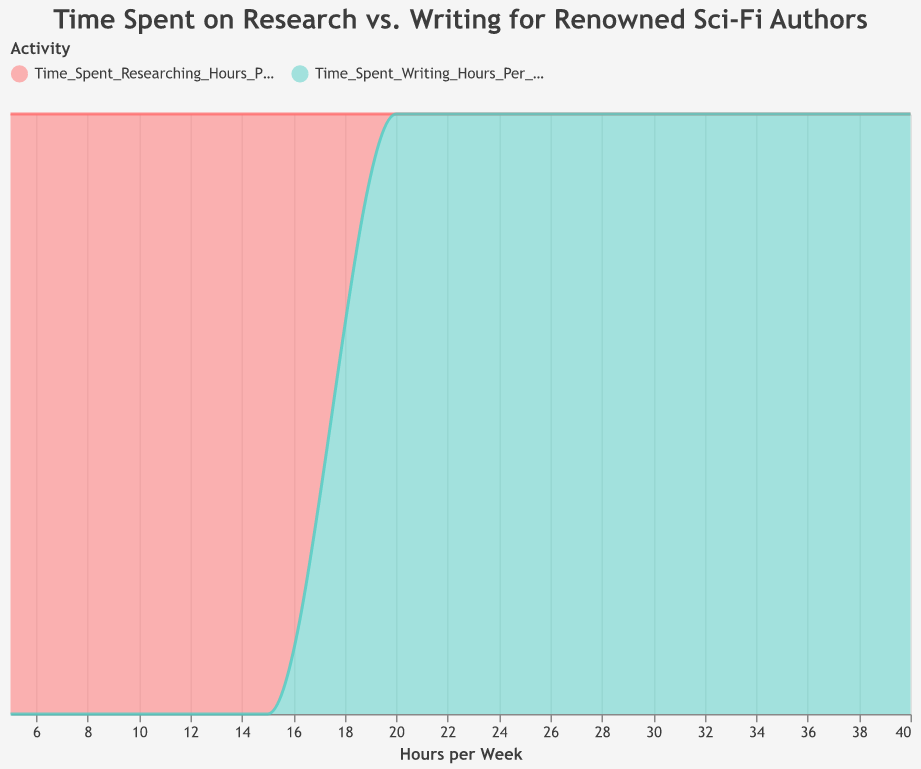How many different activities are plotted in the density plot? Look at the legend in the figure, which specifies the different activities plotted. In this case, the legend mentions "Researching" and "Writing".
Answer: 2 What is the activity associated with a given red color? Check the colors in the legend. The red color corresponds to one of the plotted activities. Based on the information, red is for "Researching".
Answer: Researching Which activity has a higher peak density, researching or writing? Observe the density curves for both activities. The peak of the green curve representing "Writing" is higher than the red curve representing "Researching".
Answer: Writing At what hour value do both activities intersect in their density plots? Look at the point where the red (Researching) and green (Writing) curves intersect on the x-axis. This occurs around 10 hours per week.
Answer: 10 hours Who spends the least amount of time researching per week? Identify the author with the minimum value on the research axis. Ray Bradbury spends the least time researching at 5 hours per week.
Answer: Ray Bradbury Which authors spend between 10 and 15 hours researching and 30 to 35 hours writing per week? From the table given, filter out authors who meet this criterion. Isaac Asimov and H.G. Wells fit these criteria.
Answer: Isaac Asimov and H.G. Wells What is the time difference between the average hours spent writing and researching? Calculate the averages: (30+25+20+35+40+28+25+27+32+30)/10 = 29.2 for writing, and (10+8+12+15+5+7+10+9+6+13)/10 = 9.5 for researching. The difference is 29.2 - 9.5 = 19.7 hours.
Answer: 19.7 hours Who spends more time writing compared to researching? Identify authors whose writing hours are greater than their researching hours. All listed authors meet this criterion.
Answer: All authors Which activity has a tighter concentration around its average value based on the density plots? Evaluate which activity's curve is narrower and taller, indicating a tighter concentration. Here, the curve for "Writing" appears to be more concentrated around its average.
Answer: Writing What is the maximum value for time spent writing recorded in the data? By referring to the table, identify the highest value in the hours spent writing column. Ray Bradbury spends the most at 40 hours per week.
Answer: 40 hours 